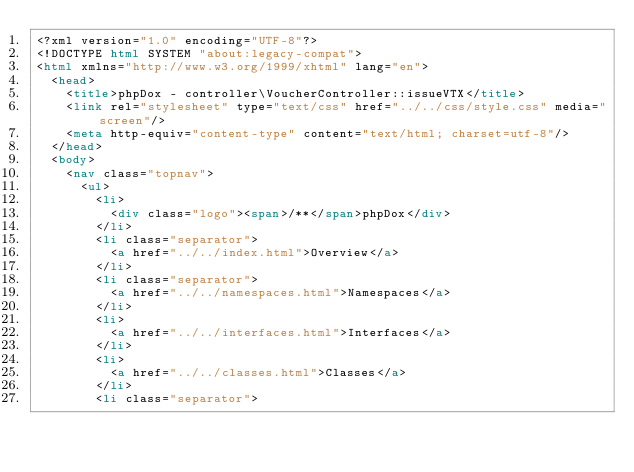<code> <loc_0><loc_0><loc_500><loc_500><_HTML_><?xml version="1.0" encoding="UTF-8"?>
<!DOCTYPE html SYSTEM "about:legacy-compat">
<html xmlns="http://www.w3.org/1999/xhtml" lang="en">
  <head>
    <title>phpDox - controller\VoucherController::issueVTX</title>
    <link rel="stylesheet" type="text/css" href="../../css/style.css" media="screen"/>
    <meta http-equiv="content-type" content="text/html; charset=utf-8"/>
  </head>
  <body>
    <nav class="topnav">
      <ul>
        <li>
          <div class="logo"><span>/**</span>phpDox</div>
        </li>
        <li class="separator">
          <a href="../../index.html">Overview</a>
        </li>
        <li class="separator">
          <a href="../../namespaces.html">Namespaces</a>
        </li>
        <li>
          <a href="../../interfaces.html">Interfaces</a>
        </li>
        <li>
          <a href="../../classes.html">Classes</a>
        </li>
        <li class="separator"></code> 